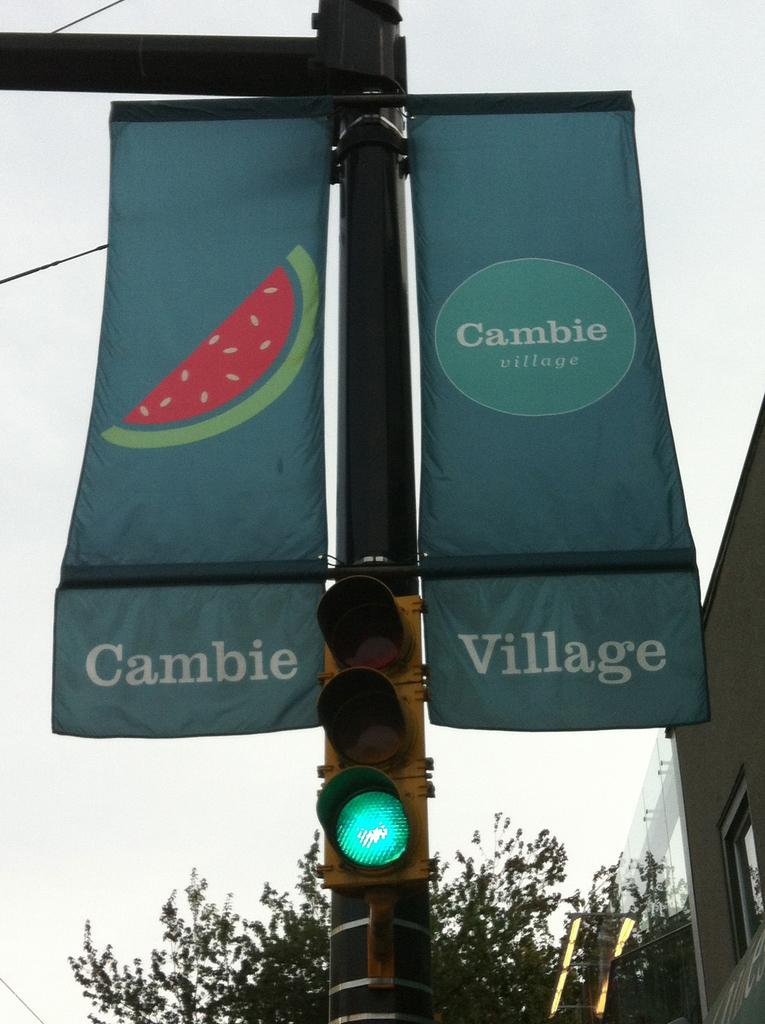<image>
Render a clear and concise summary of the photo. Two flags for Cambie Village sit on the street light one is bearing a watermelon 